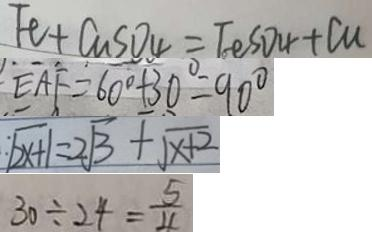<formula> <loc_0><loc_0><loc_500><loc_500>F e + C u S O _ { 4 } = F e S O _ { 4 } + C u 
 E A F = 6 0 ^ { \circ } + 3 0 ^ { \circ } = 9 0 ^ { \circ } 
 : \sqrt { 2 x + 1 } = 2 \sqrt { 3 } + \sqrt { x + 2 } 
 3 0 \div 2 4 = \frac { 5 } { 4 }</formula> 